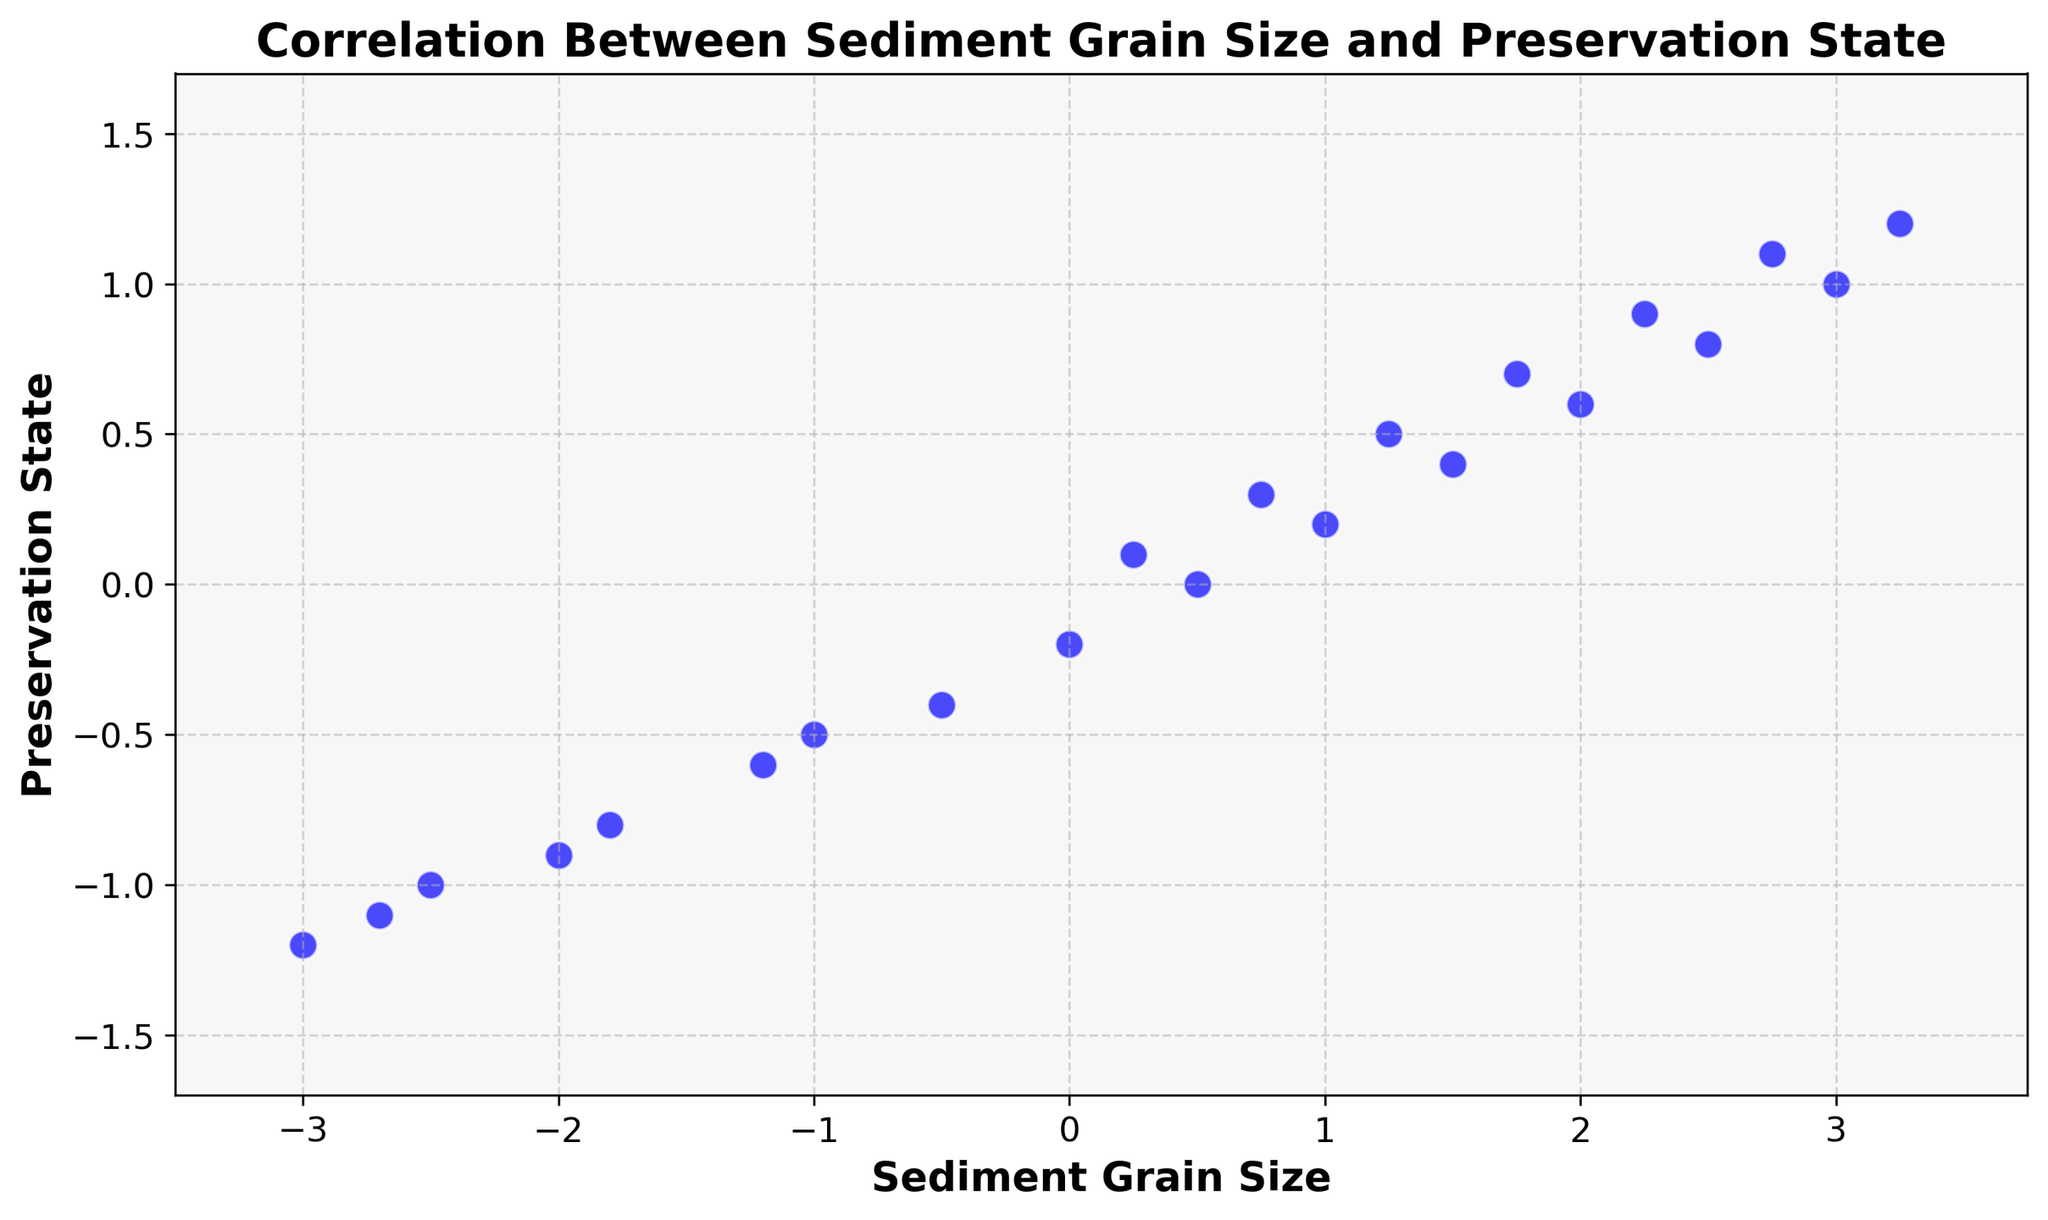What are the minimum and maximum sediment grain sizes in the plot? The minimum sediment grain size can be identified by looking at the furthest data point to the left, and the maximum sediment grain size can be identified by looking at the furthest data point to the right. The minimum is -3.0 and the maximum is 3.25.
Answer: -3.0 and 3.25 Is there a positive correlation between sediment grain size and preservation state? By examining the general trend in the scatter plot, if the data points form an upward slope from left to right, it indicates a positive correlation. In this plot, the data points tend to form an upward slope, which indicates a positive correlation.
Answer: Yes Which sediment grain size corresponds to the highest preservation state? To find the highest preservation state, look for the data point positioned the highest on the y-axis. Then, check its corresponding x-axis value. The highest preservation state is 1.2, and its corresponding sediment grain size is 3.25.
Answer: 3.25 Count the number of data points that have a positive preservation state. Count all the data points that are located above the x-axis (where preservation state > 0). There are 12 data points above the x-axis.
Answer: 12 How many data points have a sediment grain size greater than 2.0 and a preservation state less than 1.0? Identify the data points in the scatter plot that are to the right of the 2.0 mark on the x-axis and below the 1.0 mark on the y-axis. There are 2 such data points.
Answer: 2 What is the preservation state when the sediment grain size is 0? Find the data point where the sediment grain size is 0 and read its corresponding y-axis value. The corresponding preservation state is -0.2.
Answer: -0.2 How does the preservation state change as the sediment grain size goes from -3.0 to 3.0? Observe the trend of data points from the leftmost (sediment grain size -3.0) to the rightmost (sediment grain size 3.0). The preservation state increases from -1.2 to 1.0, indicating an increasing trend.
Answer: Increases What sediment grain size has a preservation state of 0.5? Locate the data point that corresponds to a preservation state of 0.5 and check its x-axis value. The sediment grain size is 1.25.
Answer: 1.25 